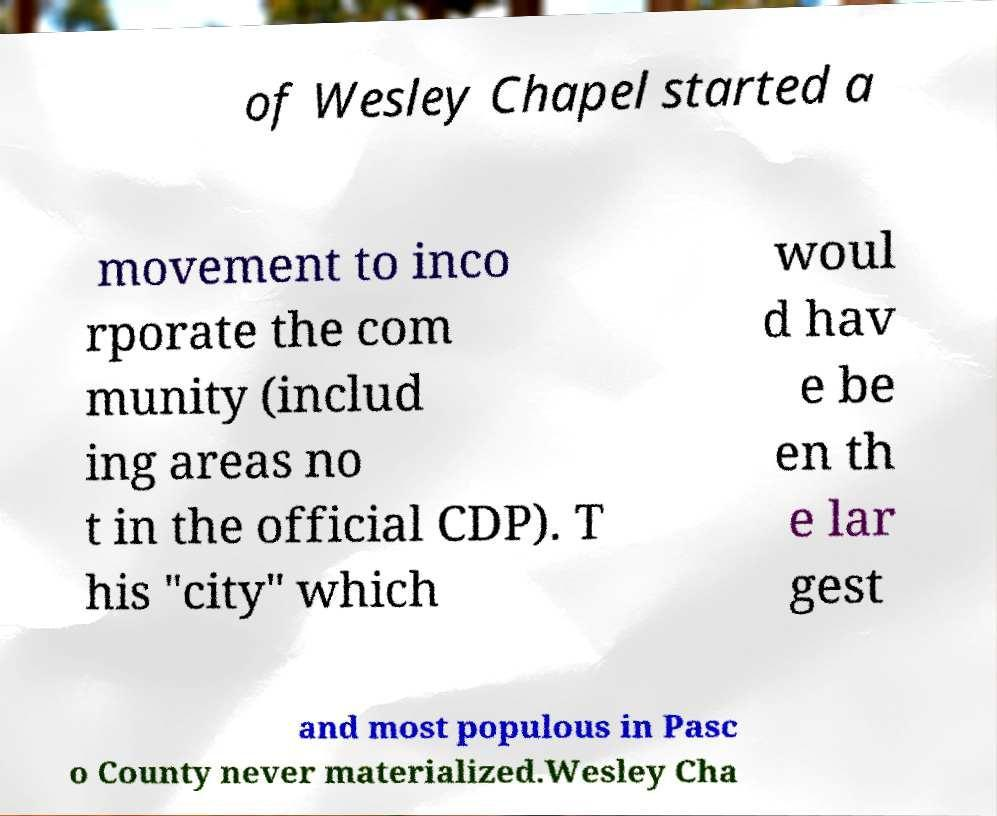Please read and relay the text visible in this image. What does it say? of Wesley Chapel started a movement to inco rporate the com munity (includ ing areas no t in the official CDP). T his "city" which woul d hav e be en th e lar gest and most populous in Pasc o County never materialized.Wesley Cha 